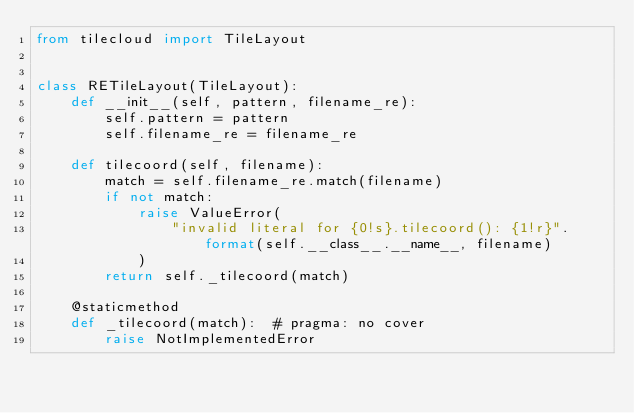<code> <loc_0><loc_0><loc_500><loc_500><_Python_>from tilecloud import TileLayout


class RETileLayout(TileLayout):
    def __init__(self, pattern, filename_re):
        self.pattern = pattern
        self.filename_re = filename_re

    def tilecoord(self, filename):
        match = self.filename_re.match(filename)
        if not match:
            raise ValueError(
                "invalid literal for {0!s}.tilecoord(): {1!r}".format(self.__class__.__name__, filename)
            )
        return self._tilecoord(match)

    @staticmethod
    def _tilecoord(match):  # pragma: no cover
        raise NotImplementedError
</code> 